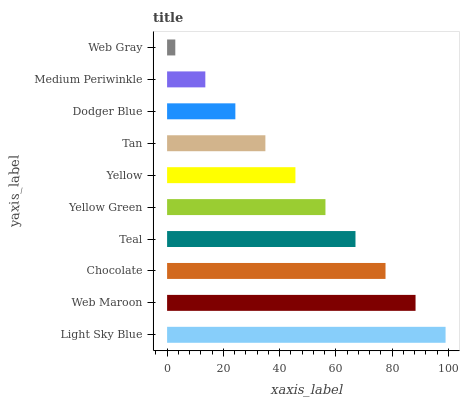Is Web Gray the minimum?
Answer yes or no. Yes. Is Light Sky Blue the maximum?
Answer yes or no. Yes. Is Web Maroon the minimum?
Answer yes or no. No. Is Web Maroon the maximum?
Answer yes or no. No. Is Light Sky Blue greater than Web Maroon?
Answer yes or no. Yes. Is Web Maroon less than Light Sky Blue?
Answer yes or no. Yes. Is Web Maroon greater than Light Sky Blue?
Answer yes or no. No. Is Light Sky Blue less than Web Maroon?
Answer yes or no. No. Is Yellow Green the high median?
Answer yes or no. Yes. Is Yellow the low median?
Answer yes or no. Yes. Is Tan the high median?
Answer yes or no. No. Is Light Sky Blue the low median?
Answer yes or no. No. 